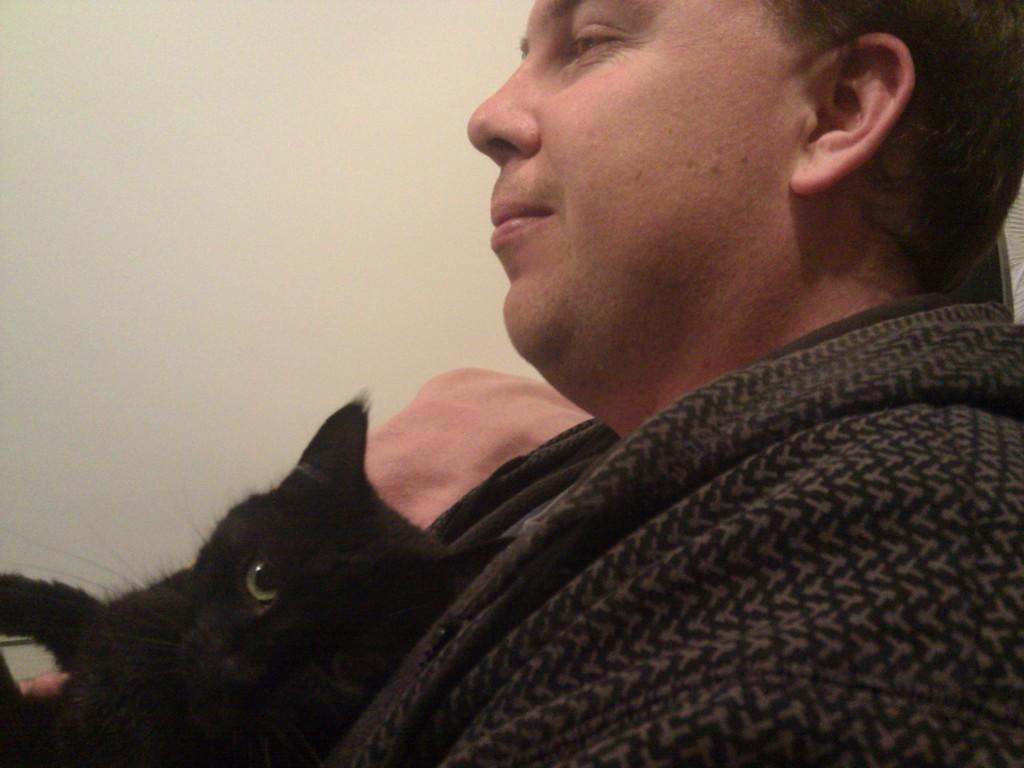What is the main subject of the image? The main subject of the image is a man. What other living creature is present in the image? There is a cat in the image. How is the cat positioned in relation to the man? The cat is on the man. What type of honey is the cat using to sweeten its food in the image? There is no honey present in the image, and the cat is not shown interacting with any food. What type of glove is the man wearing in the image? There is no glove visible on the man in the image. 